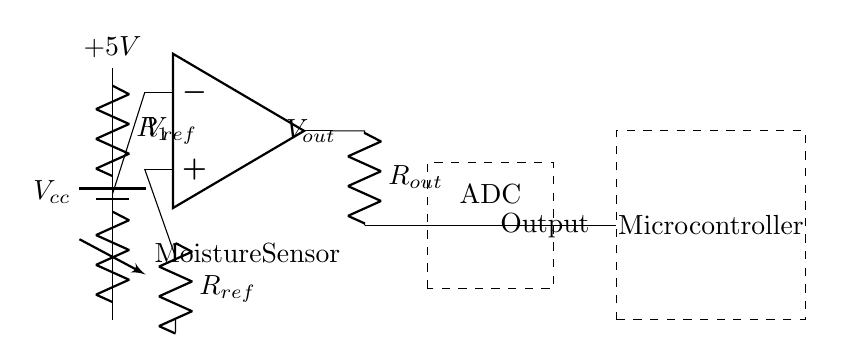What is the voltage of the power supply? The circuit uses a battery labeled as \( V_{cc} \), which indicates a power supply voltage of 5 volts.
Answer: 5 volts What type of sensor is used in this circuit? The circuit diagram shows a component labeled as "Moisture Sensor," indicating that the sensor used to detect dryness levels is specifically for moisture measurement.
Answer: Moisture Sensor What function does the op-amp serve in the circuit? The operational amplifier (op-amp) is used as a comparator, which compares the voltage coming from the moisture sensor with a reference voltage labeled \( R_{ref} \). This function is essential in determining whether the moisture level in the clay is above or below a certain threshold.
Answer: Comparator What is the role of the ADC in this circuit? The ADC, or Analog-to-Digital Converter, is responsible for converting the analog output voltage from the op-amp into a digital signal that the microcontroller can process, allowing the moisture levels to be digitally analyzed.
Answer: Conversion Which component is responsible for adjusting the sensitivity of the moisture sensor? The variable resistor, denoted in the circuit as "Moisture Sensor," can be adjusted to change the resistance, thereby adjusting the sensitivity of the moisture detection.
Answer: Variable resistor What is the output label from the op-amp? The output from the operational amplifier is labeled as \( V_{out} \), which represents the voltage output that indicates the condition of the moisture level being detected in the circuit.
Answer: V-out 